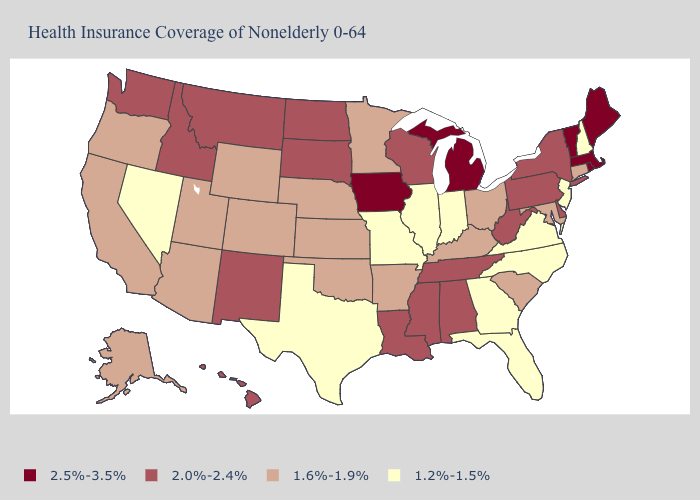Among the states that border Kentucky , does Tennessee have the lowest value?
Concise answer only. No. What is the value of New Jersey?
Write a very short answer. 1.2%-1.5%. Which states have the lowest value in the USA?
Be succinct. Florida, Georgia, Illinois, Indiana, Missouri, Nevada, New Hampshire, New Jersey, North Carolina, Texas, Virginia. What is the value of Maryland?
Answer briefly. 1.6%-1.9%. Name the states that have a value in the range 2.0%-2.4%?
Short answer required. Alabama, Delaware, Hawaii, Idaho, Louisiana, Mississippi, Montana, New Mexico, New York, North Dakota, Pennsylvania, South Dakota, Tennessee, Washington, West Virginia, Wisconsin. Does Alaska have the same value as Connecticut?
Answer briefly. Yes. What is the lowest value in states that border Wisconsin?
Quick response, please. 1.2%-1.5%. Does Massachusetts have the lowest value in the USA?
Keep it brief. No. Name the states that have a value in the range 1.6%-1.9%?
Concise answer only. Alaska, Arizona, Arkansas, California, Colorado, Connecticut, Kansas, Kentucky, Maryland, Minnesota, Nebraska, Ohio, Oklahoma, Oregon, South Carolina, Utah, Wyoming. Does New Jersey have the highest value in the USA?
Be succinct. No. What is the value of Arizona?
Short answer required. 1.6%-1.9%. Which states hav the highest value in the Northeast?
Give a very brief answer. Maine, Massachusetts, Rhode Island, Vermont. Name the states that have a value in the range 2.0%-2.4%?
Be succinct. Alabama, Delaware, Hawaii, Idaho, Louisiana, Mississippi, Montana, New Mexico, New York, North Dakota, Pennsylvania, South Dakota, Tennessee, Washington, West Virginia, Wisconsin. Does Ohio have the same value as Maryland?
Write a very short answer. Yes. Does the map have missing data?
Be succinct. No. 